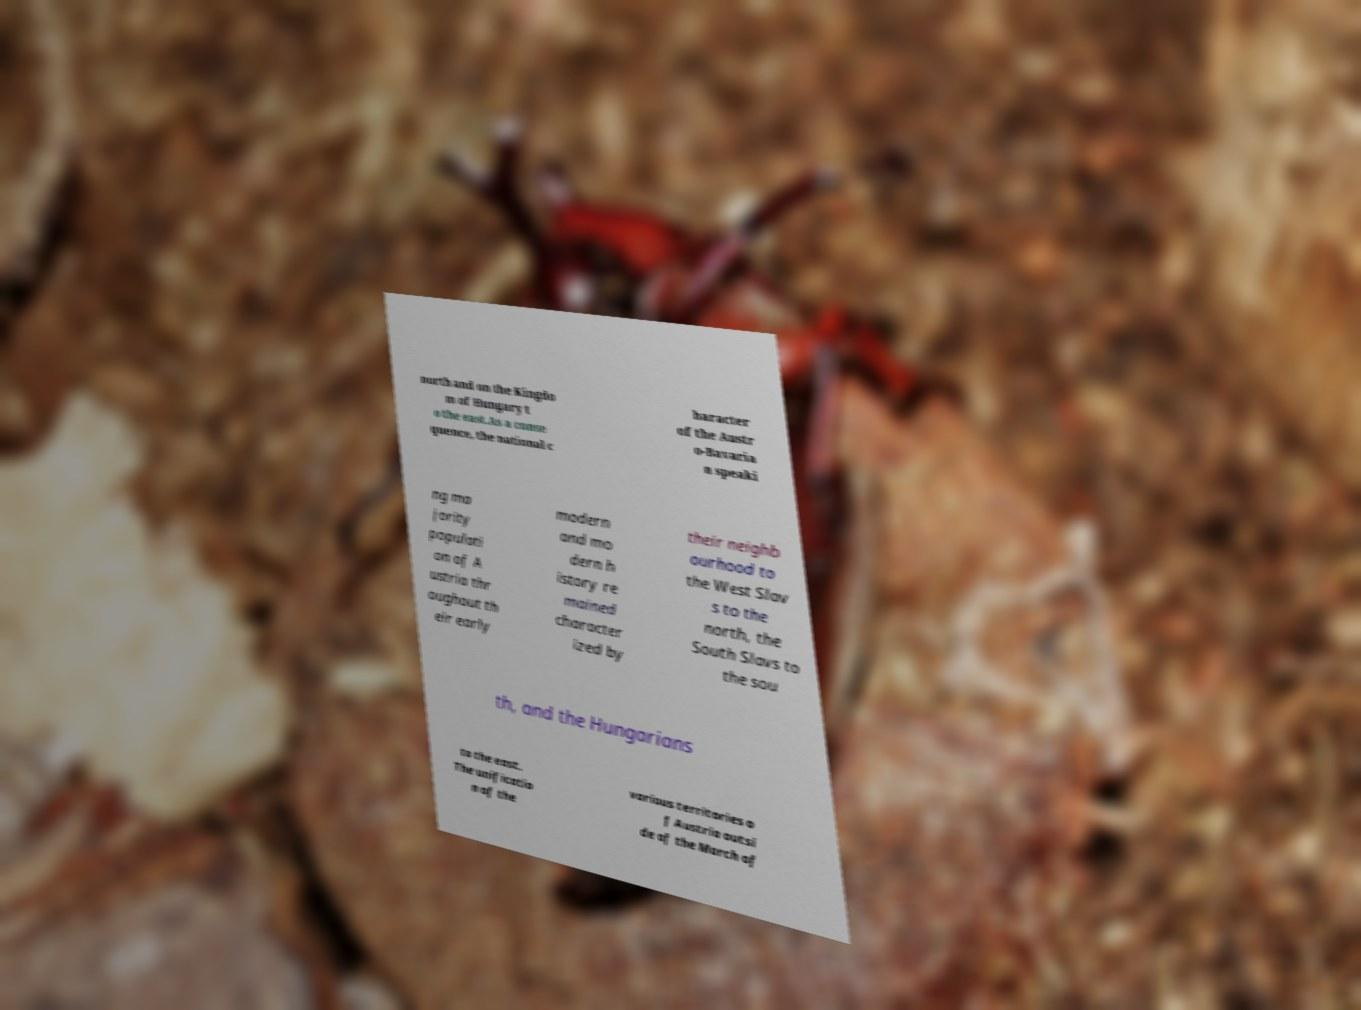Could you assist in decoding the text presented in this image and type it out clearly? north and on the Kingdo m of Hungary t o the east.As a conse quence, the national c haracter of the Austr o-Bavaria n speaki ng ma jority populati on of A ustria thr oughout th eir early modern and mo dern h istory re mained character ized by their neighb ourhood to the West Slav s to the north, the South Slavs to the sou th, and the Hungarians to the east. The unificatio n of the various territories o f Austria outsi de of the March of 